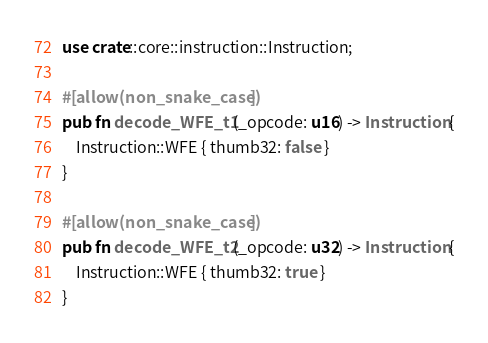<code> <loc_0><loc_0><loc_500><loc_500><_Rust_>use crate::core::instruction::Instruction;

#[allow(non_snake_case)]
pub fn decode_WFE_t1(_opcode: u16) -> Instruction {
    Instruction::WFE { thumb32: false }
}

#[allow(non_snake_case)]
pub fn decode_WFE_t2(_opcode: u32) -> Instruction {
    Instruction::WFE { thumb32: true }
}
</code> 